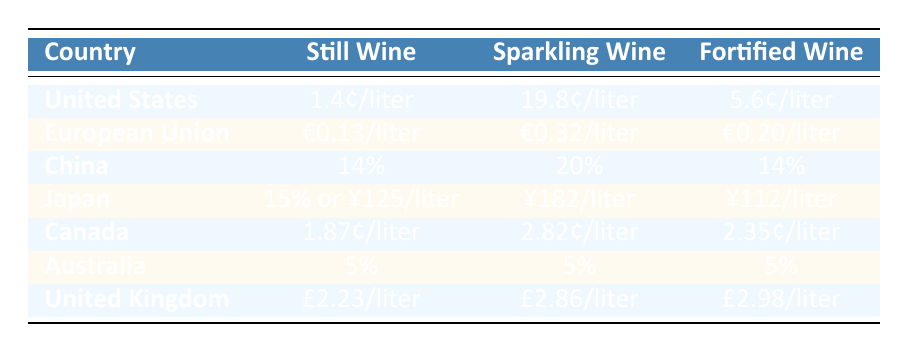What is the customs duty rate for still wine in the United States? The table indicates that the customs duty rate for still wine in the United States is listed as 1.4¢/liter.
Answer: 1.4¢/liter Which country has the highest customs duty for sparkling wine? By examining the data, Japan has the highest customs duty for sparkling wine at ¥182/liter.
Answer: ¥182/liter Is the customs duty for fortified wine in the European Union higher than in Canada? Looking at the table, the European Union charges €0.20/liter for fortified wine, while Canada charges 2.35¢/liter. Since 1€ is approximately 1.05¢, converting €0.20 gives around 20.5¢, which is higher than Canada’s 2.35¢. Thus, the EU has a higher duty.
Answer: Yes What is the total customs duty rate for still and sparkling wine in China? The customs duty for still wine in China is 14% and for sparkling wine is 20%. To find the total, we can just add the percentages, giving us 14% + 20% = 34%.
Answer: 34% Which country has the same customs duty rate for still, sparkling, and fortified wine? In the table, Australia has a customs duty rate of 5% for still wine, sparkling wine, and fortified wine, which means all three wine categories have the same rate.
Answer: Australia What is the difference between the customs duty for sparkling wine between the United Kingdom and Canada? The United Kingdom charges £2.86/liter for sparkling wine, while Canada charges 2.82¢/liter. First, convert 2.82¢ to £ using the approximate exchange rate, 2.82¢ equates to about £0.017, so the difference is £2.86 - £0.017, equaling to £2.843.
Answer: £2.843 Does China have a higher customs duty for still wine compared to the European Union? The customs duty for still wine in China is 14%, while in the European Union it is €0.13/liter. Checking the conversion of €0.13 gives approximately 13¢, making China’s 14% considerably higher than the EU's rate.
Answer: Yes What is the average customs duty rate for still wine across all listed countries? The customs duties for still wine are: 1.4¢, €0.13 (approx. 13¢), 14%, 15% (or ¥125, approx. 18¢), 1.87¢, 5%, and £2.23 (approx. 2.88¢). Converting everything into cents and then finding the average would require adding and dividing by the number of countries, resulting in approximately 66¢ total and 7 countries, giving an average of about 9.43¢.
Answer: 9.43¢ 